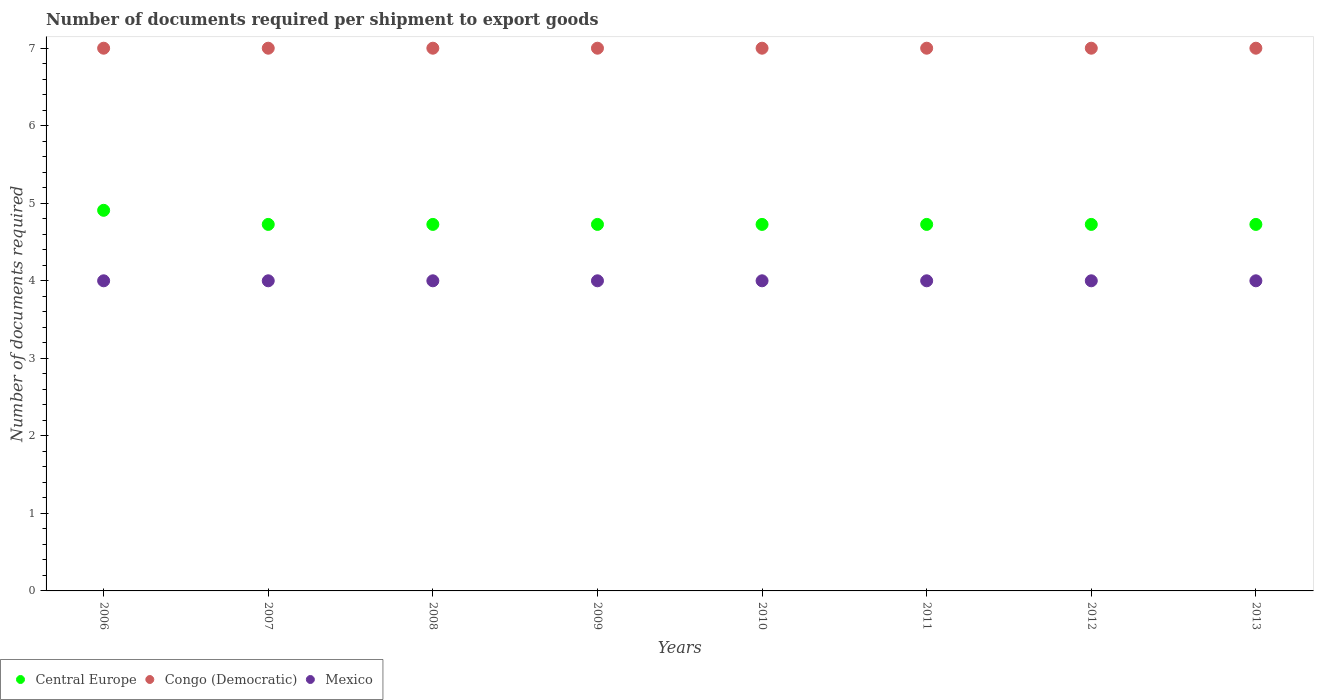How many different coloured dotlines are there?
Provide a short and direct response. 3. Is the number of dotlines equal to the number of legend labels?
Your answer should be very brief. Yes. What is the number of documents required per shipment to export goods in Mexico in 2012?
Your response must be concise. 4. Across all years, what is the maximum number of documents required per shipment to export goods in Central Europe?
Your response must be concise. 4.91. Across all years, what is the minimum number of documents required per shipment to export goods in Congo (Democratic)?
Offer a terse response. 7. What is the total number of documents required per shipment to export goods in Central Europe in the graph?
Offer a very short reply. 38. What is the difference between the number of documents required per shipment to export goods in Congo (Democratic) in 2011 and the number of documents required per shipment to export goods in Central Europe in 2009?
Offer a very short reply. 2.27. In the year 2007, what is the difference between the number of documents required per shipment to export goods in Central Europe and number of documents required per shipment to export goods in Congo (Democratic)?
Ensure brevity in your answer.  -2.27. In how many years, is the number of documents required per shipment to export goods in Congo (Democratic) greater than 6.8?
Your response must be concise. 8. What is the difference between the highest and the second highest number of documents required per shipment to export goods in Mexico?
Offer a terse response. 0. What is the difference between the highest and the lowest number of documents required per shipment to export goods in Central Europe?
Your answer should be compact. 0.18. Is the number of documents required per shipment to export goods in Mexico strictly less than the number of documents required per shipment to export goods in Central Europe over the years?
Offer a terse response. Yes. How many dotlines are there?
Your answer should be very brief. 3. How many years are there in the graph?
Offer a terse response. 8. Does the graph contain any zero values?
Offer a terse response. No. Does the graph contain grids?
Your response must be concise. No. Where does the legend appear in the graph?
Keep it short and to the point. Bottom left. What is the title of the graph?
Offer a very short reply. Number of documents required per shipment to export goods. What is the label or title of the Y-axis?
Your answer should be compact. Number of documents required. What is the Number of documents required of Central Europe in 2006?
Your response must be concise. 4.91. What is the Number of documents required in Mexico in 2006?
Offer a terse response. 4. What is the Number of documents required in Central Europe in 2007?
Your response must be concise. 4.73. What is the Number of documents required in Central Europe in 2008?
Your answer should be very brief. 4.73. What is the Number of documents required of Mexico in 2008?
Make the answer very short. 4. What is the Number of documents required in Central Europe in 2009?
Offer a terse response. 4.73. What is the Number of documents required in Congo (Democratic) in 2009?
Provide a succinct answer. 7. What is the Number of documents required in Mexico in 2009?
Your response must be concise. 4. What is the Number of documents required of Central Europe in 2010?
Offer a terse response. 4.73. What is the Number of documents required in Central Europe in 2011?
Provide a short and direct response. 4.73. What is the Number of documents required in Congo (Democratic) in 2011?
Provide a succinct answer. 7. What is the Number of documents required of Central Europe in 2012?
Provide a succinct answer. 4.73. What is the Number of documents required of Congo (Democratic) in 2012?
Ensure brevity in your answer.  7. What is the Number of documents required of Central Europe in 2013?
Keep it short and to the point. 4.73. What is the Number of documents required in Congo (Democratic) in 2013?
Ensure brevity in your answer.  7. What is the Number of documents required in Mexico in 2013?
Provide a succinct answer. 4. Across all years, what is the maximum Number of documents required in Central Europe?
Ensure brevity in your answer.  4.91. Across all years, what is the minimum Number of documents required of Central Europe?
Provide a succinct answer. 4.73. Across all years, what is the minimum Number of documents required of Congo (Democratic)?
Offer a very short reply. 7. What is the total Number of documents required of Mexico in the graph?
Offer a very short reply. 32. What is the difference between the Number of documents required of Central Europe in 2006 and that in 2007?
Keep it short and to the point. 0.18. What is the difference between the Number of documents required in Congo (Democratic) in 2006 and that in 2007?
Keep it short and to the point. 0. What is the difference between the Number of documents required in Central Europe in 2006 and that in 2008?
Provide a short and direct response. 0.18. What is the difference between the Number of documents required of Mexico in 2006 and that in 2008?
Make the answer very short. 0. What is the difference between the Number of documents required in Central Europe in 2006 and that in 2009?
Keep it short and to the point. 0.18. What is the difference between the Number of documents required in Central Europe in 2006 and that in 2010?
Offer a very short reply. 0.18. What is the difference between the Number of documents required of Congo (Democratic) in 2006 and that in 2010?
Keep it short and to the point. 0. What is the difference between the Number of documents required in Mexico in 2006 and that in 2010?
Ensure brevity in your answer.  0. What is the difference between the Number of documents required in Central Europe in 2006 and that in 2011?
Ensure brevity in your answer.  0.18. What is the difference between the Number of documents required in Congo (Democratic) in 2006 and that in 2011?
Make the answer very short. 0. What is the difference between the Number of documents required in Central Europe in 2006 and that in 2012?
Offer a terse response. 0.18. What is the difference between the Number of documents required of Congo (Democratic) in 2006 and that in 2012?
Keep it short and to the point. 0. What is the difference between the Number of documents required of Mexico in 2006 and that in 2012?
Give a very brief answer. 0. What is the difference between the Number of documents required in Central Europe in 2006 and that in 2013?
Give a very brief answer. 0.18. What is the difference between the Number of documents required in Congo (Democratic) in 2006 and that in 2013?
Offer a very short reply. 0. What is the difference between the Number of documents required in Central Europe in 2007 and that in 2008?
Your response must be concise. 0. What is the difference between the Number of documents required in Mexico in 2007 and that in 2008?
Ensure brevity in your answer.  0. What is the difference between the Number of documents required of Central Europe in 2007 and that in 2009?
Your answer should be very brief. 0. What is the difference between the Number of documents required of Congo (Democratic) in 2007 and that in 2010?
Your answer should be compact. 0. What is the difference between the Number of documents required of Central Europe in 2007 and that in 2011?
Offer a very short reply. 0. What is the difference between the Number of documents required of Mexico in 2007 and that in 2011?
Keep it short and to the point. 0. What is the difference between the Number of documents required in Central Europe in 2007 and that in 2012?
Keep it short and to the point. 0. What is the difference between the Number of documents required of Mexico in 2007 and that in 2012?
Provide a short and direct response. 0. What is the difference between the Number of documents required of Central Europe in 2007 and that in 2013?
Make the answer very short. 0. What is the difference between the Number of documents required of Mexico in 2007 and that in 2013?
Offer a very short reply. 0. What is the difference between the Number of documents required in Central Europe in 2008 and that in 2009?
Your answer should be compact. 0. What is the difference between the Number of documents required of Congo (Democratic) in 2008 and that in 2009?
Offer a very short reply. 0. What is the difference between the Number of documents required of Mexico in 2008 and that in 2009?
Provide a succinct answer. 0. What is the difference between the Number of documents required in Mexico in 2008 and that in 2010?
Make the answer very short. 0. What is the difference between the Number of documents required in Central Europe in 2008 and that in 2011?
Provide a short and direct response. 0. What is the difference between the Number of documents required in Mexico in 2008 and that in 2011?
Offer a very short reply. 0. What is the difference between the Number of documents required in Congo (Democratic) in 2008 and that in 2012?
Make the answer very short. 0. What is the difference between the Number of documents required in Mexico in 2008 and that in 2013?
Your response must be concise. 0. What is the difference between the Number of documents required of Central Europe in 2009 and that in 2010?
Keep it short and to the point. 0. What is the difference between the Number of documents required in Congo (Democratic) in 2009 and that in 2010?
Your response must be concise. 0. What is the difference between the Number of documents required in Congo (Democratic) in 2009 and that in 2011?
Offer a very short reply. 0. What is the difference between the Number of documents required of Mexico in 2009 and that in 2011?
Your response must be concise. 0. What is the difference between the Number of documents required of Central Europe in 2009 and that in 2012?
Ensure brevity in your answer.  0. What is the difference between the Number of documents required of Congo (Democratic) in 2009 and that in 2012?
Give a very brief answer. 0. What is the difference between the Number of documents required in Central Europe in 2009 and that in 2013?
Give a very brief answer. 0. What is the difference between the Number of documents required in Central Europe in 2010 and that in 2011?
Make the answer very short. 0. What is the difference between the Number of documents required of Mexico in 2010 and that in 2011?
Keep it short and to the point. 0. What is the difference between the Number of documents required of Central Europe in 2010 and that in 2012?
Offer a very short reply. 0. What is the difference between the Number of documents required in Congo (Democratic) in 2010 and that in 2012?
Provide a succinct answer. 0. What is the difference between the Number of documents required of Mexico in 2010 and that in 2012?
Offer a very short reply. 0. What is the difference between the Number of documents required of Congo (Democratic) in 2010 and that in 2013?
Ensure brevity in your answer.  0. What is the difference between the Number of documents required of Central Europe in 2011 and that in 2013?
Offer a terse response. 0. What is the difference between the Number of documents required of Congo (Democratic) in 2011 and that in 2013?
Offer a very short reply. 0. What is the difference between the Number of documents required in Mexico in 2011 and that in 2013?
Offer a terse response. 0. What is the difference between the Number of documents required of Mexico in 2012 and that in 2013?
Give a very brief answer. 0. What is the difference between the Number of documents required of Central Europe in 2006 and the Number of documents required of Congo (Democratic) in 2007?
Give a very brief answer. -2.09. What is the difference between the Number of documents required of Central Europe in 2006 and the Number of documents required of Mexico in 2007?
Offer a terse response. 0.91. What is the difference between the Number of documents required of Central Europe in 2006 and the Number of documents required of Congo (Democratic) in 2008?
Give a very brief answer. -2.09. What is the difference between the Number of documents required of Congo (Democratic) in 2006 and the Number of documents required of Mexico in 2008?
Make the answer very short. 3. What is the difference between the Number of documents required of Central Europe in 2006 and the Number of documents required of Congo (Democratic) in 2009?
Your response must be concise. -2.09. What is the difference between the Number of documents required of Central Europe in 2006 and the Number of documents required of Mexico in 2009?
Offer a terse response. 0.91. What is the difference between the Number of documents required in Congo (Democratic) in 2006 and the Number of documents required in Mexico in 2009?
Your answer should be compact. 3. What is the difference between the Number of documents required of Central Europe in 2006 and the Number of documents required of Congo (Democratic) in 2010?
Give a very brief answer. -2.09. What is the difference between the Number of documents required of Central Europe in 2006 and the Number of documents required of Mexico in 2010?
Make the answer very short. 0.91. What is the difference between the Number of documents required in Central Europe in 2006 and the Number of documents required in Congo (Democratic) in 2011?
Your response must be concise. -2.09. What is the difference between the Number of documents required in Congo (Democratic) in 2006 and the Number of documents required in Mexico in 2011?
Ensure brevity in your answer.  3. What is the difference between the Number of documents required in Central Europe in 2006 and the Number of documents required in Congo (Democratic) in 2012?
Keep it short and to the point. -2.09. What is the difference between the Number of documents required of Central Europe in 2006 and the Number of documents required of Mexico in 2012?
Provide a succinct answer. 0.91. What is the difference between the Number of documents required of Congo (Democratic) in 2006 and the Number of documents required of Mexico in 2012?
Offer a terse response. 3. What is the difference between the Number of documents required of Central Europe in 2006 and the Number of documents required of Congo (Democratic) in 2013?
Your answer should be compact. -2.09. What is the difference between the Number of documents required of Central Europe in 2006 and the Number of documents required of Mexico in 2013?
Your response must be concise. 0.91. What is the difference between the Number of documents required of Central Europe in 2007 and the Number of documents required of Congo (Democratic) in 2008?
Your response must be concise. -2.27. What is the difference between the Number of documents required in Central Europe in 2007 and the Number of documents required in Mexico in 2008?
Provide a short and direct response. 0.73. What is the difference between the Number of documents required in Central Europe in 2007 and the Number of documents required in Congo (Democratic) in 2009?
Provide a succinct answer. -2.27. What is the difference between the Number of documents required in Central Europe in 2007 and the Number of documents required in Mexico in 2009?
Provide a succinct answer. 0.73. What is the difference between the Number of documents required of Congo (Democratic) in 2007 and the Number of documents required of Mexico in 2009?
Provide a short and direct response. 3. What is the difference between the Number of documents required in Central Europe in 2007 and the Number of documents required in Congo (Democratic) in 2010?
Your response must be concise. -2.27. What is the difference between the Number of documents required of Central Europe in 2007 and the Number of documents required of Mexico in 2010?
Your response must be concise. 0.73. What is the difference between the Number of documents required of Central Europe in 2007 and the Number of documents required of Congo (Democratic) in 2011?
Offer a terse response. -2.27. What is the difference between the Number of documents required of Central Europe in 2007 and the Number of documents required of Mexico in 2011?
Provide a succinct answer. 0.73. What is the difference between the Number of documents required of Congo (Democratic) in 2007 and the Number of documents required of Mexico in 2011?
Ensure brevity in your answer.  3. What is the difference between the Number of documents required of Central Europe in 2007 and the Number of documents required of Congo (Democratic) in 2012?
Your answer should be compact. -2.27. What is the difference between the Number of documents required of Central Europe in 2007 and the Number of documents required of Mexico in 2012?
Make the answer very short. 0.73. What is the difference between the Number of documents required in Congo (Democratic) in 2007 and the Number of documents required in Mexico in 2012?
Give a very brief answer. 3. What is the difference between the Number of documents required in Central Europe in 2007 and the Number of documents required in Congo (Democratic) in 2013?
Your response must be concise. -2.27. What is the difference between the Number of documents required of Central Europe in 2007 and the Number of documents required of Mexico in 2013?
Your response must be concise. 0.73. What is the difference between the Number of documents required of Congo (Democratic) in 2007 and the Number of documents required of Mexico in 2013?
Provide a succinct answer. 3. What is the difference between the Number of documents required of Central Europe in 2008 and the Number of documents required of Congo (Democratic) in 2009?
Offer a terse response. -2.27. What is the difference between the Number of documents required in Central Europe in 2008 and the Number of documents required in Mexico in 2009?
Provide a succinct answer. 0.73. What is the difference between the Number of documents required in Congo (Democratic) in 2008 and the Number of documents required in Mexico in 2009?
Give a very brief answer. 3. What is the difference between the Number of documents required of Central Europe in 2008 and the Number of documents required of Congo (Democratic) in 2010?
Ensure brevity in your answer.  -2.27. What is the difference between the Number of documents required of Central Europe in 2008 and the Number of documents required of Mexico in 2010?
Your response must be concise. 0.73. What is the difference between the Number of documents required of Central Europe in 2008 and the Number of documents required of Congo (Democratic) in 2011?
Ensure brevity in your answer.  -2.27. What is the difference between the Number of documents required of Central Europe in 2008 and the Number of documents required of Mexico in 2011?
Provide a short and direct response. 0.73. What is the difference between the Number of documents required of Congo (Democratic) in 2008 and the Number of documents required of Mexico in 2011?
Make the answer very short. 3. What is the difference between the Number of documents required of Central Europe in 2008 and the Number of documents required of Congo (Democratic) in 2012?
Your answer should be very brief. -2.27. What is the difference between the Number of documents required of Central Europe in 2008 and the Number of documents required of Mexico in 2012?
Your response must be concise. 0.73. What is the difference between the Number of documents required of Congo (Democratic) in 2008 and the Number of documents required of Mexico in 2012?
Offer a very short reply. 3. What is the difference between the Number of documents required in Central Europe in 2008 and the Number of documents required in Congo (Democratic) in 2013?
Keep it short and to the point. -2.27. What is the difference between the Number of documents required of Central Europe in 2008 and the Number of documents required of Mexico in 2013?
Keep it short and to the point. 0.73. What is the difference between the Number of documents required in Central Europe in 2009 and the Number of documents required in Congo (Democratic) in 2010?
Provide a succinct answer. -2.27. What is the difference between the Number of documents required in Central Europe in 2009 and the Number of documents required in Mexico in 2010?
Keep it short and to the point. 0.73. What is the difference between the Number of documents required of Congo (Democratic) in 2009 and the Number of documents required of Mexico in 2010?
Give a very brief answer. 3. What is the difference between the Number of documents required of Central Europe in 2009 and the Number of documents required of Congo (Democratic) in 2011?
Your answer should be compact. -2.27. What is the difference between the Number of documents required of Central Europe in 2009 and the Number of documents required of Mexico in 2011?
Ensure brevity in your answer.  0.73. What is the difference between the Number of documents required in Congo (Democratic) in 2009 and the Number of documents required in Mexico in 2011?
Give a very brief answer. 3. What is the difference between the Number of documents required of Central Europe in 2009 and the Number of documents required of Congo (Democratic) in 2012?
Make the answer very short. -2.27. What is the difference between the Number of documents required in Central Europe in 2009 and the Number of documents required in Mexico in 2012?
Give a very brief answer. 0.73. What is the difference between the Number of documents required of Congo (Democratic) in 2009 and the Number of documents required of Mexico in 2012?
Give a very brief answer. 3. What is the difference between the Number of documents required in Central Europe in 2009 and the Number of documents required in Congo (Democratic) in 2013?
Keep it short and to the point. -2.27. What is the difference between the Number of documents required in Central Europe in 2009 and the Number of documents required in Mexico in 2013?
Your answer should be compact. 0.73. What is the difference between the Number of documents required in Congo (Democratic) in 2009 and the Number of documents required in Mexico in 2013?
Give a very brief answer. 3. What is the difference between the Number of documents required of Central Europe in 2010 and the Number of documents required of Congo (Democratic) in 2011?
Your response must be concise. -2.27. What is the difference between the Number of documents required of Central Europe in 2010 and the Number of documents required of Mexico in 2011?
Give a very brief answer. 0.73. What is the difference between the Number of documents required of Congo (Democratic) in 2010 and the Number of documents required of Mexico in 2011?
Ensure brevity in your answer.  3. What is the difference between the Number of documents required in Central Europe in 2010 and the Number of documents required in Congo (Democratic) in 2012?
Make the answer very short. -2.27. What is the difference between the Number of documents required in Central Europe in 2010 and the Number of documents required in Mexico in 2012?
Your answer should be very brief. 0.73. What is the difference between the Number of documents required in Congo (Democratic) in 2010 and the Number of documents required in Mexico in 2012?
Give a very brief answer. 3. What is the difference between the Number of documents required of Central Europe in 2010 and the Number of documents required of Congo (Democratic) in 2013?
Keep it short and to the point. -2.27. What is the difference between the Number of documents required of Central Europe in 2010 and the Number of documents required of Mexico in 2013?
Give a very brief answer. 0.73. What is the difference between the Number of documents required of Central Europe in 2011 and the Number of documents required of Congo (Democratic) in 2012?
Ensure brevity in your answer.  -2.27. What is the difference between the Number of documents required in Central Europe in 2011 and the Number of documents required in Mexico in 2012?
Ensure brevity in your answer.  0.73. What is the difference between the Number of documents required of Central Europe in 2011 and the Number of documents required of Congo (Democratic) in 2013?
Your answer should be compact. -2.27. What is the difference between the Number of documents required of Central Europe in 2011 and the Number of documents required of Mexico in 2013?
Provide a succinct answer. 0.73. What is the difference between the Number of documents required of Central Europe in 2012 and the Number of documents required of Congo (Democratic) in 2013?
Provide a short and direct response. -2.27. What is the difference between the Number of documents required of Central Europe in 2012 and the Number of documents required of Mexico in 2013?
Keep it short and to the point. 0.73. What is the difference between the Number of documents required of Congo (Democratic) in 2012 and the Number of documents required of Mexico in 2013?
Keep it short and to the point. 3. What is the average Number of documents required in Central Europe per year?
Keep it short and to the point. 4.75. What is the average Number of documents required in Mexico per year?
Make the answer very short. 4. In the year 2006, what is the difference between the Number of documents required of Central Europe and Number of documents required of Congo (Democratic)?
Give a very brief answer. -2.09. In the year 2006, what is the difference between the Number of documents required in Congo (Democratic) and Number of documents required in Mexico?
Give a very brief answer. 3. In the year 2007, what is the difference between the Number of documents required in Central Europe and Number of documents required in Congo (Democratic)?
Your answer should be very brief. -2.27. In the year 2007, what is the difference between the Number of documents required of Central Europe and Number of documents required of Mexico?
Offer a terse response. 0.73. In the year 2007, what is the difference between the Number of documents required in Congo (Democratic) and Number of documents required in Mexico?
Offer a very short reply. 3. In the year 2008, what is the difference between the Number of documents required in Central Europe and Number of documents required in Congo (Democratic)?
Offer a terse response. -2.27. In the year 2008, what is the difference between the Number of documents required in Central Europe and Number of documents required in Mexico?
Give a very brief answer. 0.73. In the year 2008, what is the difference between the Number of documents required of Congo (Democratic) and Number of documents required of Mexico?
Provide a short and direct response. 3. In the year 2009, what is the difference between the Number of documents required in Central Europe and Number of documents required in Congo (Democratic)?
Offer a terse response. -2.27. In the year 2009, what is the difference between the Number of documents required of Central Europe and Number of documents required of Mexico?
Offer a very short reply. 0.73. In the year 2009, what is the difference between the Number of documents required of Congo (Democratic) and Number of documents required of Mexico?
Give a very brief answer. 3. In the year 2010, what is the difference between the Number of documents required of Central Europe and Number of documents required of Congo (Democratic)?
Your response must be concise. -2.27. In the year 2010, what is the difference between the Number of documents required of Central Europe and Number of documents required of Mexico?
Keep it short and to the point. 0.73. In the year 2010, what is the difference between the Number of documents required in Congo (Democratic) and Number of documents required in Mexico?
Keep it short and to the point. 3. In the year 2011, what is the difference between the Number of documents required of Central Europe and Number of documents required of Congo (Democratic)?
Give a very brief answer. -2.27. In the year 2011, what is the difference between the Number of documents required in Central Europe and Number of documents required in Mexico?
Provide a succinct answer. 0.73. In the year 2011, what is the difference between the Number of documents required of Congo (Democratic) and Number of documents required of Mexico?
Offer a very short reply. 3. In the year 2012, what is the difference between the Number of documents required in Central Europe and Number of documents required in Congo (Democratic)?
Provide a short and direct response. -2.27. In the year 2012, what is the difference between the Number of documents required in Central Europe and Number of documents required in Mexico?
Your answer should be very brief. 0.73. In the year 2012, what is the difference between the Number of documents required of Congo (Democratic) and Number of documents required of Mexico?
Your response must be concise. 3. In the year 2013, what is the difference between the Number of documents required of Central Europe and Number of documents required of Congo (Democratic)?
Provide a short and direct response. -2.27. In the year 2013, what is the difference between the Number of documents required in Central Europe and Number of documents required in Mexico?
Your answer should be very brief. 0.73. In the year 2013, what is the difference between the Number of documents required of Congo (Democratic) and Number of documents required of Mexico?
Offer a very short reply. 3. What is the ratio of the Number of documents required in Central Europe in 2006 to that in 2007?
Your answer should be compact. 1.04. What is the ratio of the Number of documents required of Central Europe in 2006 to that in 2008?
Provide a short and direct response. 1.04. What is the ratio of the Number of documents required of Congo (Democratic) in 2006 to that in 2008?
Provide a short and direct response. 1. What is the ratio of the Number of documents required in Congo (Democratic) in 2006 to that in 2009?
Offer a very short reply. 1. What is the ratio of the Number of documents required of Central Europe in 2006 to that in 2010?
Give a very brief answer. 1.04. What is the ratio of the Number of documents required of Congo (Democratic) in 2006 to that in 2010?
Offer a terse response. 1. What is the ratio of the Number of documents required in Congo (Democratic) in 2006 to that in 2011?
Offer a terse response. 1. What is the ratio of the Number of documents required in Mexico in 2006 to that in 2011?
Make the answer very short. 1. What is the ratio of the Number of documents required in Congo (Democratic) in 2006 to that in 2012?
Provide a short and direct response. 1. What is the ratio of the Number of documents required of Mexico in 2006 to that in 2013?
Ensure brevity in your answer.  1. What is the ratio of the Number of documents required of Congo (Democratic) in 2007 to that in 2008?
Provide a succinct answer. 1. What is the ratio of the Number of documents required of Central Europe in 2007 to that in 2009?
Make the answer very short. 1. What is the ratio of the Number of documents required of Congo (Democratic) in 2007 to that in 2009?
Provide a short and direct response. 1. What is the ratio of the Number of documents required of Congo (Democratic) in 2007 to that in 2010?
Your answer should be very brief. 1. What is the ratio of the Number of documents required of Mexico in 2007 to that in 2010?
Give a very brief answer. 1. What is the ratio of the Number of documents required of Central Europe in 2007 to that in 2011?
Provide a short and direct response. 1. What is the ratio of the Number of documents required in Mexico in 2007 to that in 2011?
Your answer should be very brief. 1. What is the ratio of the Number of documents required in Congo (Democratic) in 2007 to that in 2012?
Offer a terse response. 1. What is the ratio of the Number of documents required of Mexico in 2007 to that in 2012?
Make the answer very short. 1. What is the ratio of the Number of documents required in Mexico in 2007 to that in 2013?
Your answer should be very brief. 1. What is the ratio of the Number of documents required of Central Europe in 2008 to that in 2009?
Your response must be concise. 1. What is the ratio of the Number of documents required of Mexico in 2008 to that in 2009?
Offer a very short reply. 1. What is the ratio of the Number of documents required of Central Europe in 2008 to that in 2010?
Provide a short and direct response. 1. What is the ratio of the Number of documents required of Mexico in 2008 to that in 2011?
Offer a terse response. 1. What is the ratio of the Number of documents required of Central Europe in 2008 to that in 2012?
Give a very brief answer. 1. What is the ratio of the Number of documents required in Congo (Democratic) in 2008 to that in 2012?
Give a very brief answer. 1. What is the ratio of the Number of documents required of Mexico in 2008 to that in 2012?
Keep it short and to the point. 1. What is the ratio of the Number of documents required of Congo (Democratic) in 2008 to that in 2013?
Your answer should be compact. 1. What is the ratio of the Number of documents required of Mexico in 2008 to that in 2013?
Offer a terse response. 1. What is the ratio of the Number of documents required of Central Europe in 2009 to that in 2010?
Offer a very short reply. 1. What is the ratio of the Number of documents required of Mexico in 2009 to that in 2010?
Keep it short and to the point. 1. What is the ratio of the Number of documents required in Central Europe in 2009 to that in 2011?
Provide a short and direct response. 1. What is the ratio of the Number of documents required in Central Europe in 2009 to that in 2012?
Make the answer very short. 1. What is the ratio of the Number of documents required of Congo (Democratic) in 2009 to that in 2012?
Your answer should be compact. 1. What is the ratio of the Number of documents required in Central Europe in 2009 to that in 2013?
Offer a very short reply. 1. What is the ratio of the Number of documents required in Mexico in 2009 to that in 2013?
Your answer should be compact. 1. What is the ratio of the Number of documents required of Central Europe in 2010 to that in 2012?
Offer a terse response. 1. What is the ratio of the Number of documents required in Mexico in 2010 to that in 2013?
Ensure brevity in your answer.  1. What is the ratio of the Number of documents required in Congo (Democratic) in 2011 to that in 2012?
Keep it short and to the point. 1. What is the ratio of the Number of documents required of Central Europe in 2011 to that in 2013?
Your answer should be very brief. 1. What is the ratio of the Number of documents required in Mexico in 2011 to that in 2013?
Keep it short and to the point. 1. What is the ratio of the Number of documents required of Central Europe in 2012 to that in 2013?
Your answer should be compact. 1. What is the ratio of the Number of documents required in Mexico in 2012 to that in 2013?
Offer a very short reply. 1. What is the difference between the highest and the second highest Number of documents required of Central Europe?
Keep it short and to the point. 0.18. What is the difference between the highest and the second highest Number of documents required of Mexico?
Ensure brevity in your answer.  0. What is the difference between the highest and the lowest Number of documents required in Central Europe?
Provide a succinct answer. 0.18. What is the difference between the highest and the lowest Number of documents required in Congo (Democratic)?
Give a very brief answer. 0. What is the difference between the highest and the lowest Number of documents required of Mexico?
Ensure brevity in your answer.  0. 